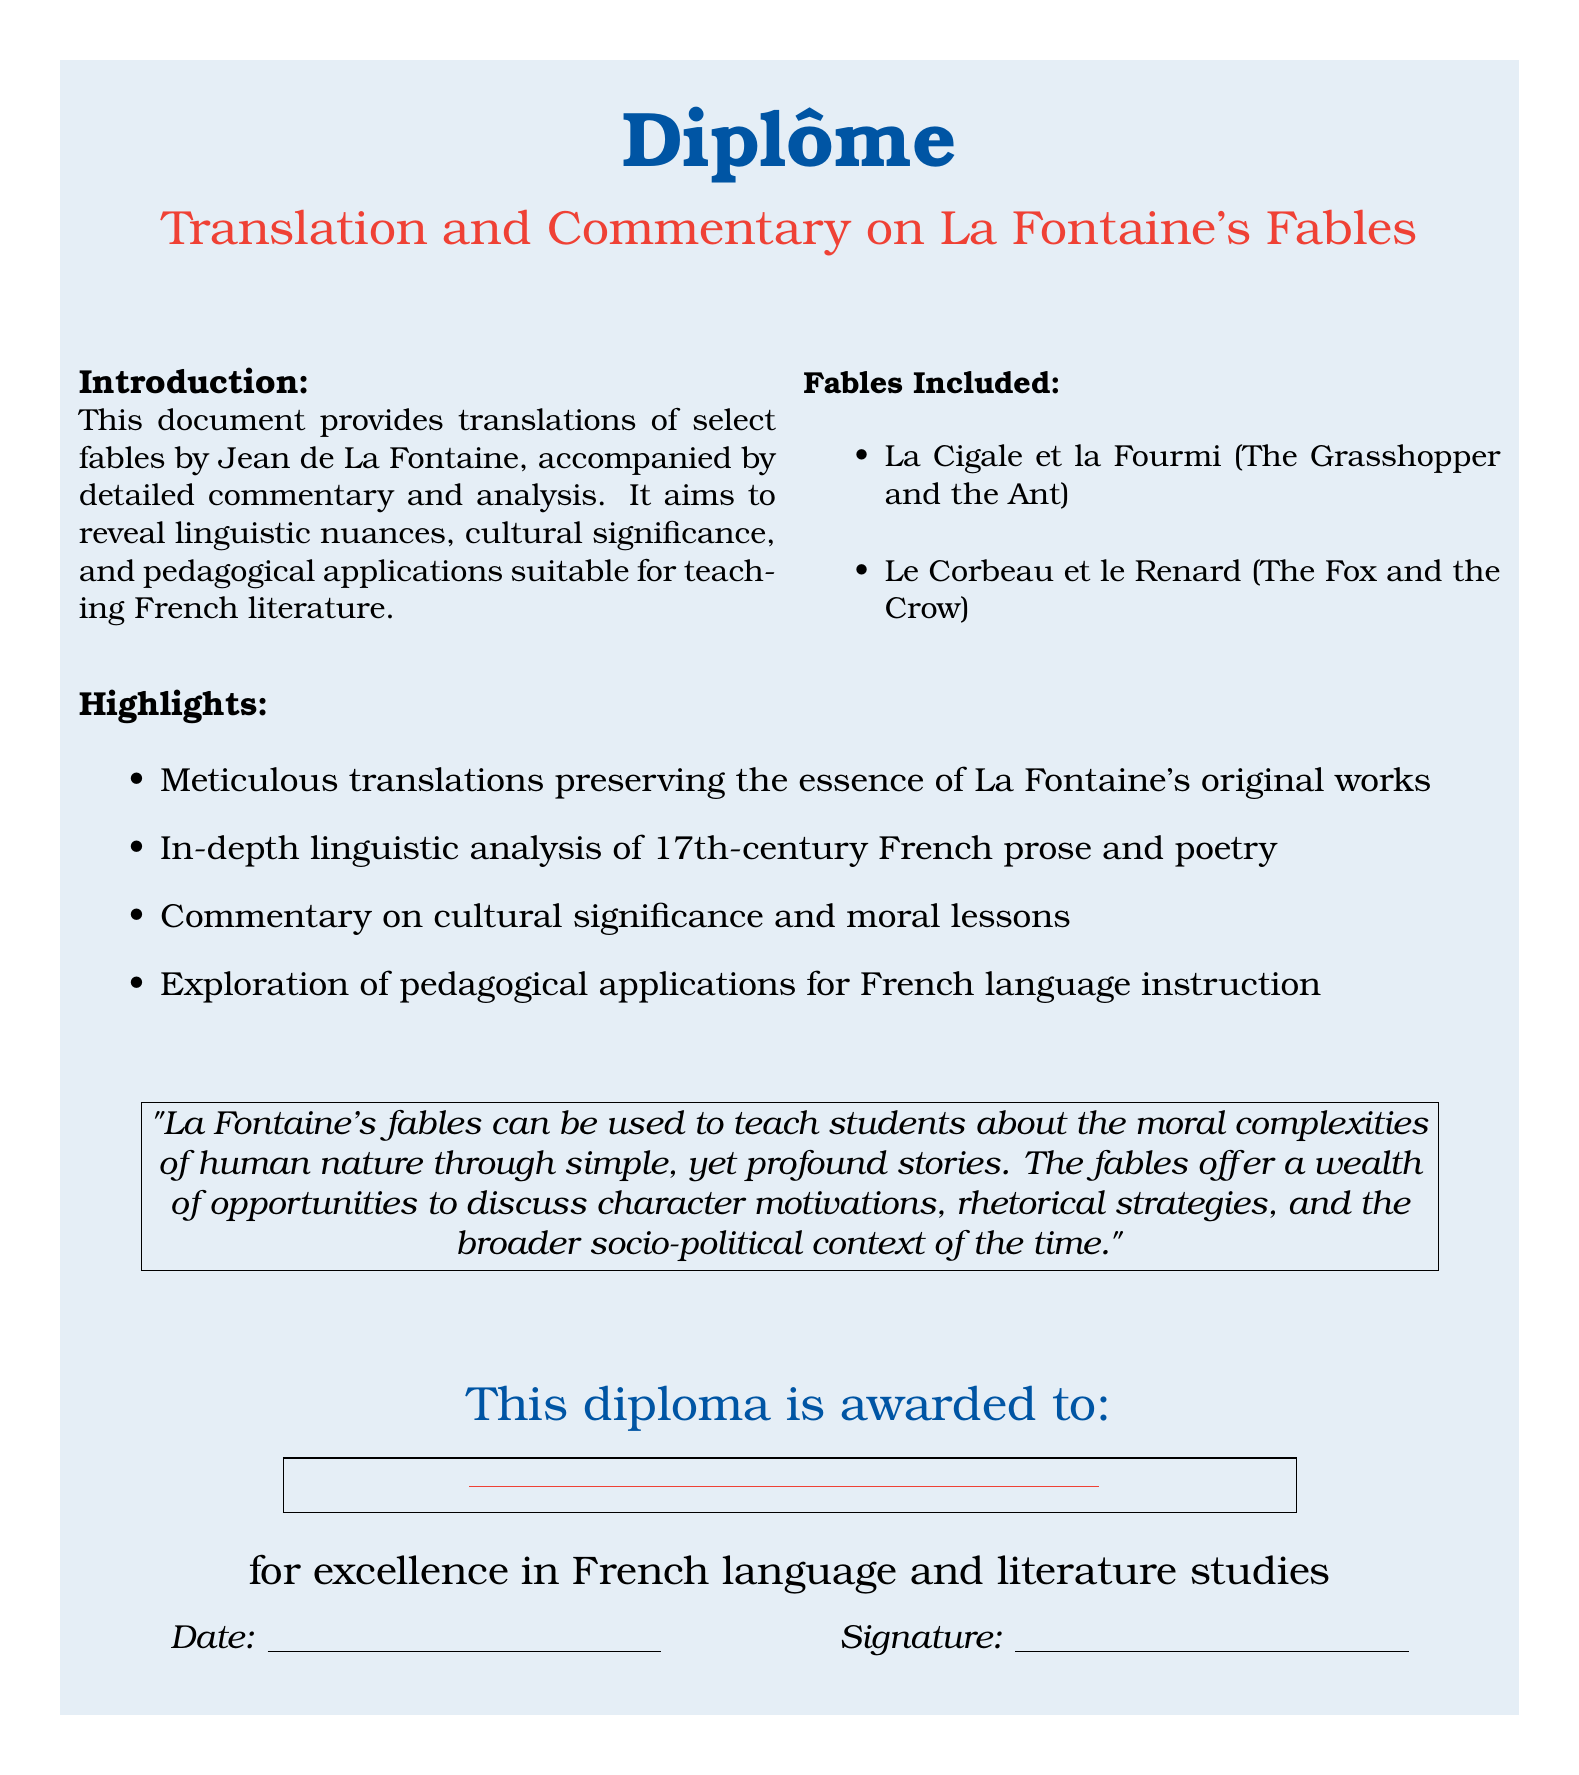What is the title of the diploma? The title of the diploma is prominently displayed in the document.
Answer: Translation and Commentary on La Fontaine's Fables Who is the document awarded to? The name of the recipient is meant to be filled in the designated space in the document.
Answer: \underline{\hspace{8cm}} What is the date format indicated in the diploma? The date is presented in a line where it can be filled in.
Answer: \underline{\hspace{5cm}} What are the two fables included in the document? The fables are listed in a bullet point format within the document.
Answer: La Cigale et la Fourmi, Le Corbeau et le Renard What type of analysis does the document provide? The document describes the type of analysis in the highlights section.
Answer: Linguistic analysis What color scheme is used for the diploma's title? The colors used for the title can be found in the visual aspects of the document.
Answer: French blue and French red How many columns are in the introduction section? The introduction section is structured into multiple columns as mentioned.
Answer: 2 What is a key pedagogical application mentioned in the document? The application is noted in the commentary regarding teaching strategies.
Answer: Teaching about moral complexities What profession is the diploma associated with? The profession is implied by the nature of the studies indicated in the diploma.
Answer: French language and literature studies 